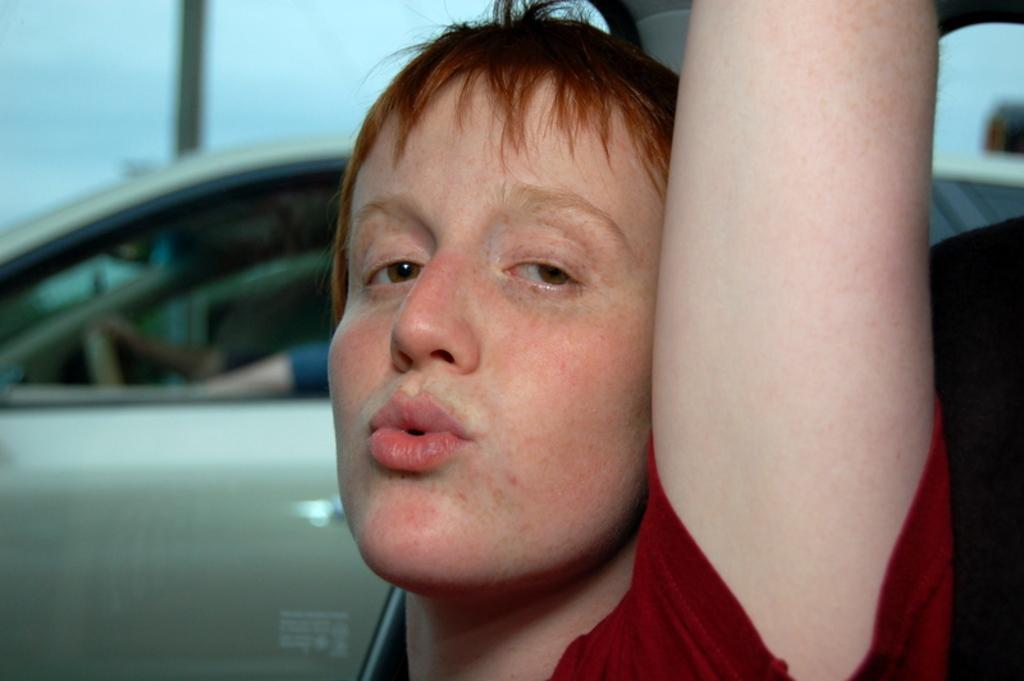Describe this image in one or two sentences. In this image, we can see a person. In the background, we can see a vehicle and the hands of a person holding a steering. 